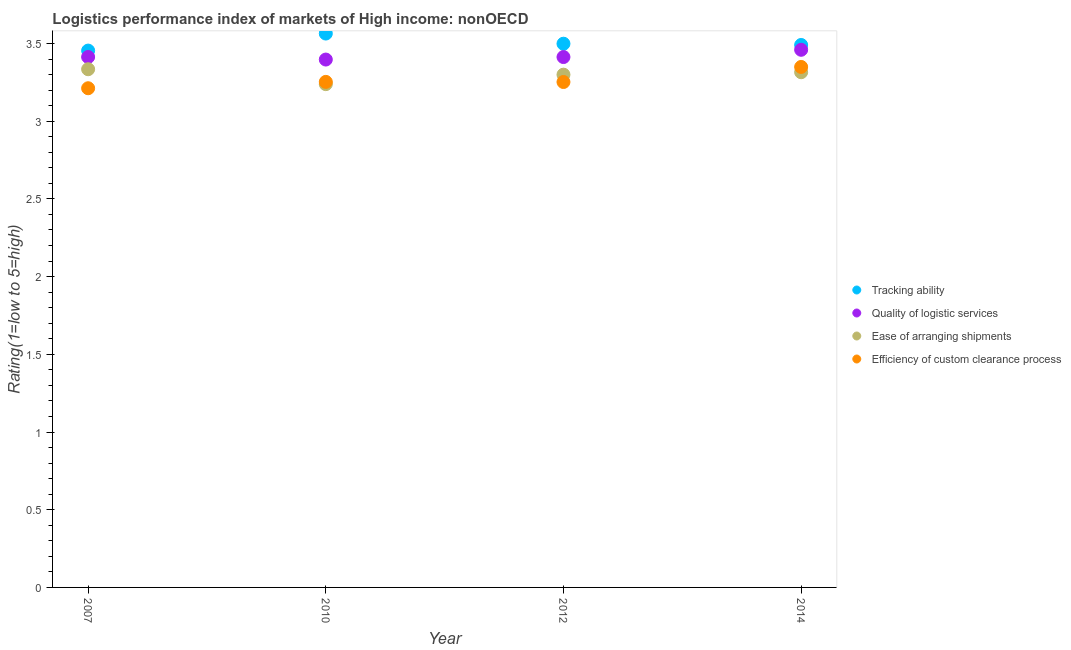What is the lpi rating of tracking ability in 2012?
Your answer should be very brief. 3.5. Across all years, what is the maximum lpi rating of tracking ability?
Make the answer very short. 3.56. Across all years, what is the minimum lpi rating of ease of arranging shipments?
Provide a succinct answer. 3.24. What is the total lpi rating of ease of arranging shipments in the graph?
Keep it short and to the point. 13.19. What is the difference between the lpi rating of efficiency of custom clearance process in 2010 and that in 2014?
Offer a terse response. -0.1. What is the difference between the lpi rating of quality of logistic services in 2014 and the lpi rating of tracking ability in 2012?
Your answer should be very brief. -0.04. What is the average lpi rating of efficiency of custom clearance process per year?
Provide a short and direct response. 3.27. In the year 2012, what is the difference between the lpi rating of efficiency of custom clearance process and lpi rating of tracking ability?
Your answer should be compact. -0.25. What is the ratio of the lpi rating of tracking ability in 2007 to that in 2012?
Provide a succinct answer. 0.99. Is the lpi rating of quality of logistic services in 2012 less than that in 2014?
Make the answer very short. Yes. What is the difference between the highest and the second highest lpi rating of quality of logistic services?
Provide a succinct answer. 0.05. What is the difference between the highest and the lowest lpi rating of efficiency of custom clearance process?
Keep it short and to the point. 0.14. Is the sum of the lpi rating of quality of logistic services in 2010 and 2012 greater than the maximum lpi rating of ease of arranging shipments across all years?
Your answer should be compact. Yes. Is it the case that in every year, the sum of the lpi rating of tracking ability and lpi rating of quality of logistic services is greater than the lpi rating of ease of arranging shipments?
Your response must be concise. Yes. Does the lpi rating of efficiency of custom clearance process monotonically increase over the years?
Your response must be concise. No. Is the lpi rating of efficiency of custom clearance process strictly less than the lpi rating of ease of arranging shipments over the years?
Your answer should be compact. No. How many dotlines are there?
Your response must be concise. 4. How many years are there in the graph?
Your response must be concise. 4. What is the difference between two consecutive major ticks on the Y-axis?
Make the answer very short. 0.5. Are the values on the major ticks of Y-axis written in scientific E-notation?
Keep it short and to the point. No. Does the graph contain any zero values?
Make the answer very short. No. What is the title of the graph?
Offer a very short reply. Logistics performance index of markets of High income: nonOECD. What is the label or title of the X-axis?
Provide a succinct answer. Year. What is the label or title of the Y-axis?
Your answer should be compact. Rating(1=low to 5=high). What is the Rating(1=low to 5=high) in Tracking ability in 2007?
Your answer should be very brief. 3.45. What is the Rating(1=low to 5=high) of Quality of logistic services in 2007?
Provide a short and direct response. 3.41. What is the Rating(1=low to 5=high) of Ease of arranging shipments in 2007?
Your response must be concise. 3.33. What is the Rating(1=low to 5=high) in Efficiency of custom clearance process in 2007?
Provide a short and direct response. 3.21. What is the Rating(1=low to 5=high) in Tracking ability in 2010?
Offer a terse response. 3.56. What is the Rating(1=low to 5=high) in Quality of logistic services in 2010?
Your answer should be compact. 3.4. What is the Rating(1=low to 5=high) of Ease of arranging shipments in 2010?
Your answer should be very brief. 3.24. What is the Rating(1=low to 5=high) in Efficiency of custom clearance process in 2010?
Your response must be concise. 3.25. What is the Rating(1=low to 5=high) of Tracking ability in 2012?
Give a very brief answer. 3.5. What is the Rating(1=low to 5=high) in Quality of logistic services in 2012?
Offer a terse response. 3.41. What is the Rating(1=low to 5=high) in Ease of arranging shipments in 2012?
Offer a terse response. 3.3. What is the Rating(1=low to 5=high) in Efficiency of custom clearance process in 2012?
Ensure brevity in your answer.  3.25. What is the Rating(1=low to 5=high) in Tracking ability in 2014?
Give a very brief answer. 3.49. What is the Rating(1=low to 5=high) in Quality of logistic services in 2014?
Your answer should be compact. 3.46. What is the Rating(1=low to 5=high) of Ease of arranging shipments in 2014?
Your answer should be very brief. 3.32. What is the Rating(1=low to 5=high) of Efficiency of custom clearance process in 2014?
Give a very brief answer. 3.35. Across all years, what is the maximum Rating(1=low to 5=high) in Tracking ability?
Provide a short and direct response. 3.56. Across all years, what is the maximum Rating(1=low to 5=high) of Quality of logistic services?
Your answer should be compact. 3.46. Across all years, what is the maximum Rating(1=low to 5=high) of Ease of arranging shipments?
Provide a short and direct response. 3.33. Across all years, what is the maximum Rating(1=low to 5=high) of Efficiency of custom clearance process?
Offer a terse response. 3.35. Across all years, what is the minimum Rating(1=low to 5=high) in Tracking ability?
Offer a very short reply. 3.45. Across all years, what is the minimum Rating(1=low to 5=high) of Quality of logistic services?
Your answer should be very brief. 3.4. Across all years, what is the minimum Rating(1=low to 5=high) of Ease of arranging shipments?
Offer a terse response. 3.24. Across all years, what is the minimum Rating(1=low to 5=high) of Efficiency of custom clearance process?
Ensure brevity in your answer.  3.21. What is the total Rating(1=low to 5=high) of Tracking ability in the graph?
Provide a short and direct response. 14.01. What is the total Rating(1=low to 5=high) of Quality of logistic services in the graph?
Ensure brevity in your answer.  13.68. What is the total Rating(1=low to 5=high) in Ease of arranging shipments in the graph?
Offer a terse response. 13.19. What is the total Rating(1=low to 5=high) in Efficiency of custom clearance process in the graph?
Ensure brevity in your answer.  13.07. What is the difference between the Rating(1=low to 5=high) in Tracking ability in 2007 and that in 2010?
Ensure brevity in your answer.  -0.11. What is the difference between the Rating(1=low to 5=high) of Quality of logistic services in 2007 and that in 2010?
Offer a very short reply. 0.02. What is the difference between the Rating(1=low to 5=high) in Ease of arranging shipments in 2007 and that in 2010?
Make the answer very short. 0.1. What is the difference between the Rating(1=low to 5=high) of Efficiency of custom clearance process in 2007 and that in 2010?
Give a very brief answer. -0.04. What is the difference between the Rating(1=low to 5=high) of Tracking ability in 2007 and that in 2012?
Keep it short and to the point. -0.04. What is the difference between the Rating(1=low to 5=high) of Ease of arranging shipments in 2007 and that in 2012?
Offer a very short reply. 0.04. What is the difference between the Rating(1=low to 5=high) of Efficiency of custom clearance process in 2007 and that in 2012?
Your answer should be compact. -0.04. What is the difference between the Rating(1=low to 5=high) in Tracking ability in 2007 and that in 2014?
Give a very brief answer. -0.04. What is the difference between the Rating(1=low to 5=high) in Quality of logistic services in 2007 and that in 2014?
Ensure brevity in your answer.  -0.05. What is the difference between the Rating(1=low to 5=high) of Ease of arranging shipments in 2007 and that in 2014?
Keep it short and to the point. 0.02. What is the difference between the Rating(1=low to 5=high) in Efficiency of custom clearance process in 2007 and that in 2014?
Your response must be concise. -0.14. What is the difference between the Rating(1=low to 5=high) in Tracking ability in 2010 and that in 2012?
Ensure brevity in your answer.  0.07. What is the difference between the Rating(1=low to 5=high) in Quality of logistic services in 2010 and that in 2012?
Give a very brief answer. -0.02. What is the difference between the Rating(1=low to 5=high) in Ease of arranging shipments in 2010 and that in 2012?
Make the answer very short. -0.06. What is the difference between the Rating(1=low to 5=high) in Efficiency of custom clearance process in 2010 and that in 2012?
Keep it short and to the point. 0. What is the difference between the Rating(1=low to 5=high) in Tracking ability in 2010 and that in 2014?
Give a very brief answer. 0.07. What is the difference between the Rating(1=low to 5=high) of Quality of logistic services in 2010 and that in 2014?
Ensure brevity in your answer.  -0.06. What is the difference between the Rating(1=low to 5=high) in Ease of arranging shipments in 2010 and that in 2014?
Your response must be concise. -0.08. What is the difference between the Rating(1=low to 5=high) in Efficiency of custom clearance process in 2010 and that in 2014?
Your answer should be very brief. -0.1. What is the difference between the Rating(1=low to 5=high) of Tracking ability in 2012 and that in 2014?
Give a very brief answer. 0.01. What is the difference between the Rating(1=low to 5=high) of Quality of logistic services in 2012 and that in 2014?
Make the answer very short. -0.05. What is the difference between the Rating(1=low to 5=high) in Ease of arranging shipments in 2012 and that in 2014?
Your answer should be compact. -0.02. What is the difference between the Rating(1=low to 5=high) in Efficiency of custom clearance process in 2012 and that in 2014?
Your answer should be compact. -0.1. What is the difference between the Rating(1=low to 5=high) of Tracking ability in 2007 and the Rating(1=low to 5=high) of Quality of logistic services in 2010?
Make the answer very short. 0.06. What is the difference between the Rating(1=low to 5=high) of Tracking ability in 2007 and the Rating(1=low to 5=high) of Ease of arranging shipments in 2010?
Provide a succinct answer. 0.22. What is the difference between the Rating(1=low to 5=high) in Tracking ability in 2007 and the Rating(1=low to 5=high) in Efficiency of custom clearance process in 2010?
Your answer should be compact. 0.2. What is the difference between the Rating(1=low to 5=high) of Quality of logistic services in 2007 and the Rating(1=low to 5=high) of Ease of arranging shipments in 2010?
Your answer should be very brief. 0.17. What is the difference between the Rating(1=low to 5=high) of Quality of logistic services in 2007 and the Rating(1=low to 5=high) of Efficiency of custom clearance process in 2010?
Ensure brevity in your answer.  0.16. What is the difference between the Rating(1=low to 5=high) of Ease of arranging shipments in 2007 and the Rating(1=low to 5=high) of Efficiency of custom clearance process in 2010?
Offer a very short reply. 0.08. What is the difference between the Rating(1=low to 5=high) of Tracking ability in 2007 and the Rating(1=low to 5=high) of Quality of logistic services in 2012?
Make the answer very short. 0.04. What is the difference between the Rating(1=low to 5=high) of Tracking ability in 2007 and the Rating(1=low to 5=high) of Ease of arranging shipments in 2012?
Your response must be concise. 0.15. What is the difference between the Rating(1=low to 5=high) of Tracking ability in 2007 and the Rating(1=low to 5=high) of Efficiency of custom clearance process in 2012?
Keep it short and to the point. 0.2. What is the difference between the Rating(1=low to 5=high) in Quality of logistic services in 2007 and the Rating(1=low to 5=high) in Ease of arranging shipments in 2012?
Your answer should be compact. 0.11. What is the difference between the Rating(1=low to 5=high) in Quality of logistic services in 2007 and the Rating(1=low to 5=high) in Efficiency of custom clearance process in 2012?
Your answer should be compact. 0.16. What is the difference between the Rating(1=low to 5=high) in Ease of arranging shipments in 2007 and the Rating(1=low to 5=high) in Efficiency of custom clearance process in 2012?
Provide a succinct answer. 0.08. What is the difference between the Rating(1=low to 5=high) of Tracking ability in 2007 and the Rating(1=low to 5=high) of Quality of logistic services in 2014?
Your answer should be compact. -0.01. What is the difference between the Rating(1=low to 5=high) of Tracking ability in 2007 and the Rating(1=low to 5=high) of Ease of arranging shipments in 2014?
Offer a very short reply. 0.14. What is the difference between the Rating(1=low to 5=high) in Tracking ability in 2007 and the Rating(1=low to 5=high) in Efficiency of custom clearance process in 2014?
Your answer should be compact. 0.11. What is the difference between the Rating(1=low to 5=high) in Quality of logistic services in 2007 and the Rating(1=low to 5=high) in Ease of arranging shipments in 2014?
Give a very brief answer. 0.1. What is the difference between the Rating(1=low to 5=high) in Quality of logistic services in 2007 and the Rating(1=low to 5=high) in Efficiency of custom clearance process in 2014?
Provide a succinct answer. 0.06. What is the difference between the Rating(1=low to 5=high) of Ease of arranging shipments in 2007 and the Rating(1=low to 5=high) of Efficiency of custom clearance process in 2014?
Offer a very short reply. -0.01. What is the difference between the Rating(1=low to 5=high) of Tracking ability in 2010 and the Rating(1=low to 5=high) of Quality of logistic services in 2012?
Provide a succinct answer. 0.15. What is the difference between the Rating(1=low to 5=high) in Tracking ability in 2010 and the Rating(1=low to 5=high) in Ease of arranging shipments in 2012?
Offer a terse response. 0.26. What is the difference between the Rating(1=low to 5=high) in Tracking ability in 2010 and the Rating(1=low to 5=high) in Efficiency of custom clearance process in 2012?
Your answer should be very brief. 0.31. What is the difference between the Rating(1=low to 5=high) in Quality of logistic services in 2010 and the Rating(1=low to 5=high) in Ease of arranging shipments in 2012?
Provide a short and direct response. 0.1. What is the difference between the Rating(1=low to 5=high) in Quality of logistic services in 2010 and the Rating(1=low to 5=high) in Efficiency of custom clearance process in 2012?
Keep it short and to the point. 0.14. What is the difference between the Rating(1=low to 5=high) in Ease of arranging shipments in 2010 and the Rating(1=low to 5=high) in Efficiency of custom clearance process in 2012?
Provide a short and direct response. -0.01. What is the difference between the Rating(1=low to 5=high) of Tracking ability in 2010 and the Rating(1=low to 5=high) of Quality of logistic services in 2014?
Make the answer very short. 0.1. What is the difference between the Rating(1=low to 5=high) of Tracking ability in 2010 and the Rating(1=low to 5=high) of Ease of arranging shipments in 2014?
Offer a terse response. 0.25. What is the difference between the Rating(1=low to 5=high) in Tracking ability in 2010 and the Rating(1=low to 5=high) in Efficiency of custom clearance process in 2014?
Provide a succinct answer. 0.21. What is the difference between the Rating(1=low to 5=high) of Quality of logistic services in 2010 and the Rating(1=low to 5=high) of Ease of arranging shipments in 2014?
Offer a very short reply. 0.08. What is the difference between the Rating(1=low to 5=high) in Quality of logistic services in 2010 and the Rating(1=low to 5=high) in Efficiency of custom clearance process in 2014?
Your response must be concise. 0.05. What is the difference between the Rating(1=low to 5=high) in Ease of arranging shipments in 2010 and the Rating(1=low to 5=high) in Efficiency of custom clearance process in 2014?
Your response must be concise. -0.11. What is the difference between the Rating(1=low to 5=high) of Tracking ability in 2012 and the Rating(1=low to 5=high) of Quality of logistic services in 2014?
Keep it short and to the point. 0.04. What is the difference between the Rating(1=low to 5=high) in Tracking ability in 2012 and the Rating(1=low to 5=high) in Ease of arranging shipments in 2014?
Your answer should be very brief. 0.18. What is the difference between the Rating(1=low to 5=high) in Tracking ability in 2012 and the Rating(1=low to 5=high) in Efficiency of custom clearance process in 2014?
Your answer should be compact. 0.15. What is the difference between the Rating(1=low to 5=high) of Quality of logistic services in 2012 and the Rating(1=low to 5=high) of Ease of arranging shipments in 2014?
Provide a short and direct response. 0.1. What is the difference between the Rating(1=low to 5=high) in Quality of logistic services in 2012 and the Rating(1=low to 5=high) in Efficiency of custom clearance process in 2014?
Offer a terse response. 0.06. What is the difference between the Rating(1=low to 5=high) of Ease of arranging shipments in 2012 and the Rating(1=low to 5=high) of Efficiency of custom clearance process in 2014?
Provide a short and direct response. -0.05. What is the average Rating(1=low to 5=high) in Tracking ability per year?
Your answer should be compact. 3.5. What is the average Rating(1=low to 5=high) in Quality of logistic services per year?
Provide a short and direct response. 3.42. What is the average Rating(1=low to 5=high) of Ease of arranging shipments per year?
Your answer should be very brief. 3.3. What is the average Rating(1=low to 5=high) in Efficiency of custom clearance process per year?
Your answer should be very brief. 3.27. In the year 2007, what is the difference between the Rating(1=low to 5=high) of Tracking ability and Rating(1=low to 5=high) of Quality of logistic services?
Your response must be concise. 0.04. In the year 2007, what is the difference between the Rating(1=low to 5=high) of Tracking ability and Rating(1=low to 5=high) of Ease of arranging shipments?
Provide a short and direct response. 0.12. In the year 2007, what is the difference between the Rating(1=low to 5=high) of Tracking ability and Rating(1=low to 5=high) of Efficiency of custom clearance process?
Make the answer very short. 0.24. In the year 2007, what is the difference between the Rating(1=low to 5=high) of Quality of logistic services and Rating(1=low to 5=high) of Ease of arranging shipments?
Keep it short and to the point. 0.08. In the year 2007, what is the difference between the Rating(1=low to 5=high) of Quality of logistic services and Rating(1=low to 5=high) of Efficiency of custom clearance process?
Your answer should be very brief. 0.2. In the year 2007, what is the difference between the Rating(1=low to 5=high) in Ease of arranging shipments and Rating(1=low to 5=high) in Efficiency of custom clearance process?
Give a very brief answer. 0.12. In the year 2010, what is the difference between the Rating(1=low to 5=high) in Tracking ability and Rating(1=low to 5=high) in Quality of logistic services?
Offer a terse response. 0.17. In the year 2010, what is the difference between the Rating(1=low to 5=high) of Tracking ability and Rating(1=low to 5=high) of Ease of arranging shipments?
Keep it short and to the point. 0.33. In the year 2010, what is the difference between the Rating(1=low to 5=high) in Tracking ability and Rating(1=low to 5=high) in Efficiency of custom clearance process?
Make the answer very short. 0.31. In the year 2010, what is the difference between the Rating(1=low to 5=high) in Quality of logistic services and Rating(1=low to 5=high) in Ease of arranging shipments?
Your answer should be very brief. 0.16. In the year 2010, what is the difference between the Rating(1=low to 5=high) in Quality of logistic services and Rating(1=low to 5=high) in Efficiency of custom clearance process?
Keep it short and to the point. 0.14. In the year 2010, what is the difference between the Rating(1=low to 5=high) of Ease of arranging shipments and Rating(1=low to 5=high) of Efficiency of custom clearance process?
Give a very brief answer. -0.01. In the year 2012, what is the difference between the Rating(1=low to 5=high) in Tracking ability and Rating(1=low to 5=high) in Quality of logistic services?
Make the answer very short. 0.09. In the year 2012, what is the difference between the Rating(1=low to 5=high) of Tracking ability and Rating(1=low to 5=high) of Ease of arranging shipments?
Provide a succinct answer. 0.2. In the year 2012, what is the difference between the Rating(1=low to 5=high) of Tracking ability and Rating(1=low to 5=high) of Efficiency of custom clearance process?
Offer a very short reply. 0.25. In the year 2012, what is the difference between the Rating(1=low to 5=high) in Quality of logistic services and Rating(1=low to 5=high) in Ease of arranging shipments?
Provide a short and direct response. 0.11. In the year 2012, what is the difference between the Rating(1=low to 5=high) of Quality of logistic services and Rating(1=low to 5=high) of Efficiency of custom clearance process?
Offer a terse response. 0.16. In the year 2012, what is the difference between the Rating(1=low to 5=high) of Ease of arranging shipments and Rating(1=low to 5=high) of Efficiency of custom clearance process?
Offer a very short reply. 0.05. In the year 2014, what is the difference between the Rating(1=low to 5=high) of Tracking ability and Rating(1=low to 5=high) of Quality of logistic services?
Your answer should be compact. 0.03. In the year 2014, what is the difference between the Rating(1=low to 5=high) in Tracking ability and Rating(1=low to 5=high) in Ease of arranging shipments?
Your answer should be compact. 0.18. In the year 2014, what is the difference between the Rating(1=low to 5=high) in Tracking ability and Rating(1=low to 5=high) in Efficiency of custom clearance process?
Keep it short and to the point. 0.14. In the year 2014, what is the difference between the Rating(1=low to 5=high) in Quality of logistic services and Rating(1=low to 5=high) in Ease of arranging shipments?
Give a very brief answer. 0.14. In the year 2014, what is the difference between the Rating(1=low to 5=high) of Quality of logistic services and Rating(1=low to 5=high) of Efficiency of custom clearance process?
Provide a succinct answer. 0.11. In the year 2014, what is the difference between the Rating(1=low to 5=high) in Ease of arranging shipments and Rating(1=low to 5=high) in Efficiency of custom clearance process?
Offer a very short reply. -0.03. What is the ratio of the Rating(1=low to 5=high) of Tracking ability in 2007 to that in 2010?
Ensure brevity in your answer.  0.97. What is the ratio of the Rating(1=low to 5=high) in Quality of logistic services in 2007 to that in 2010?
Offer a very short reply. 1. What is the ratio of the Rating(1=low to 5=high) in Ease of arranging shipments in 2007 to that in 2010?
Make the answer very short. 1.03. What is the ratio of the Rating(1=low to 5=high) in Efficiency of custom clearance process in 2007 to that in 2010?
Ensure brevity in your answer.  0.99. What is the ratio of the Rating(1=low to 5=high) in Tracking ability in 2007 to that in 2012?
Make the answer very short. 0.99. What is the ratio of the Rating(1=low to 5=high) in Quality of logistic services in 2007 to that in 2012?
Your response must be concise. 1. What is the ratio of the Rating(1=low to 5=high) in Ease of arranging shipments in 2007 to that in 2012?
Provide a short and direct response. 1.01. What is the ratio of the Rating(1=low to 5=high) in Efficiency of custom clearance process in 2007 to that in 2012?
Give a very brief answer. 0.99. What is the ratio of the Rating(1=low to 5=high) of Quality of logistic services in 2007 to that in 2014?
Offer a terse response. 0.99. What is the ratio of the Rating(1=low to 5=high) in Efficiency of custom clearance process in 2007 to that in 2014?
Offer a very short reply. 0.96. What is the ratio of the Rating(1=low to 5=high) in Tracking ability in 2010 to that in 2012?
Give a very brief answer. 1.02. What is the ratio of the Rating(1=low to 5=high) in Ease of arranging shipments in 2010 to that in 2012?
Make the answer very short. 0.98. What is the ratio of the Rating(1=low to 5=high) of Efficiency of custom clearance process in 2010 to that in 2012?
Your response must be concise. 1. What is the ratio of the Rating(1=low to 5=high) in Tracking ability in 2010 to that in 2014?
Your answer should be very brief. 1.02. What is the ratio of the Rating(1=low to 5=high) of Quality of logistic services in 2010 to that in 2014?
Your answer should be compact. 0.98. What is the ratio of the Rating(1=low to 5=high) in Ease of arranging shipments in 2010 to that in 2014?
Give a very brief answer. 0.98. What is the ratio of the Rating(1=low to 5=high) of Efficiency of custom clearance process in 2010 to that in 2014?
Provide a short and direct response. 0.97. What is the ratio of the Rating(1=low to 5=high) in Tracking ability in 2012 to that in 2014?
Offer a terse response. 1. What is the ratio of the Rating(1=low to 5=high) of Quality of logistic services in 2012 to that in 2014?
Your answer should be very brief. 0.99. What is the ratio of the Rating(1=low to 5=high) in Efficiency of custom clearance process in 2012 to that in 2014?
Your answer should be very brief. 0.97. What is the difference between the highest and the second highest Rating(1=low to 5=high) in Tracking ability?
Make the answer very short. 0.07. What is the difference between the highest and the second highest Rating(1=low to 5=high) of Quality of logistic services?
Offer a very short reply. 0.05. What is the difference between the highest and the second highest Rating(1=low to 5=high) of Ease of arranging shipments?
Your answer should be compact. 0.02. What is the difference between the highest and the second highest Rating(1=low to 5=high) in Efficiency of custom clearance process?
Keep it short and to the point. 0.1. What is the difference between the highest and the lowest Rating(1=low to 5=high) of Tracking ability?
Provide a short and direct response. 0.11. What is the difference between the highest and the lowest Rating(1=low to 5=high) in Quality of logistic services?
Give a very brief answer. 0.06. What is the difference between the highest and the lowest Rating(1=low to 5=high) in Ease of arranging shipments?
Your answer should be very brief. 0.1. What is the difference between the highest and the lowest Rating(1=low to 5=high) of Efficiency of custom clearance process?
Make the answer very short. 0.14. 